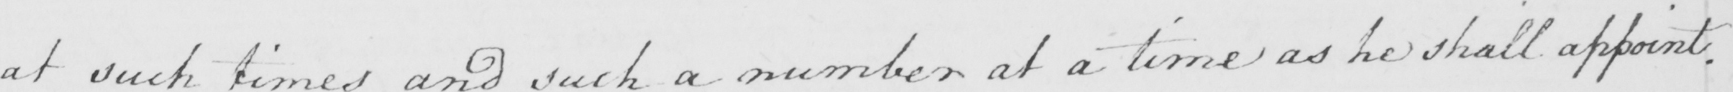What does this handwritten line say? at such times and such a number at a time as he shall appoint . 